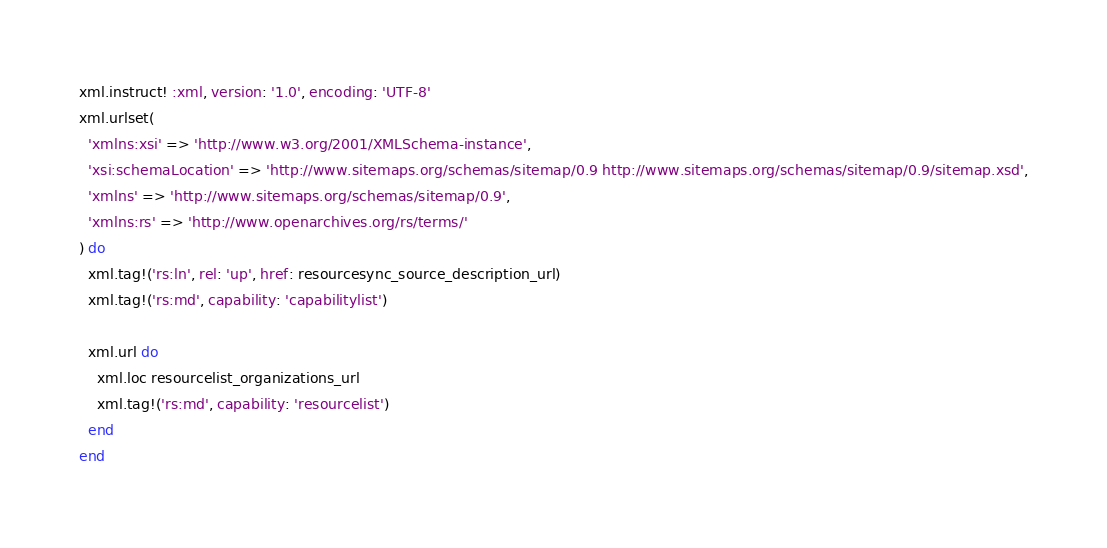<code> <loc_0><loc_0><loc_500><loc_500><_Ruby_>
xml.instruct! :xml, version: '1.0', encoding: 'UTF-8'
xml.urlset(
  'xmlns:xsi' => 'http://www.w3.org/2001/XMLSchema-instance',
  'xsi:schemaLocation' => 'http://www.sitemaps.org/schemas/sitemap/0.9 http://www.sitemaps.org/schemas/sitemap/0.9/sitemap.xsd',
  'xmlns' => 'http://www.sitemaps.org/schemas/sitemap/0.9',
  'xmlns:rs' => 'http://www.openarchives.org/rs/terms/'
) do
  xml.tag!('rs:ln', rel: 'up', href: resourcesync_source_description_url)
  xml.tag!('rs:md', capability: 'capabilitylist')

  xml.url do
    xml.loc resourcelist_organizations_url
    xml.tag!('rs:md', capability: 'resourcelist')
  end
end
</code> 